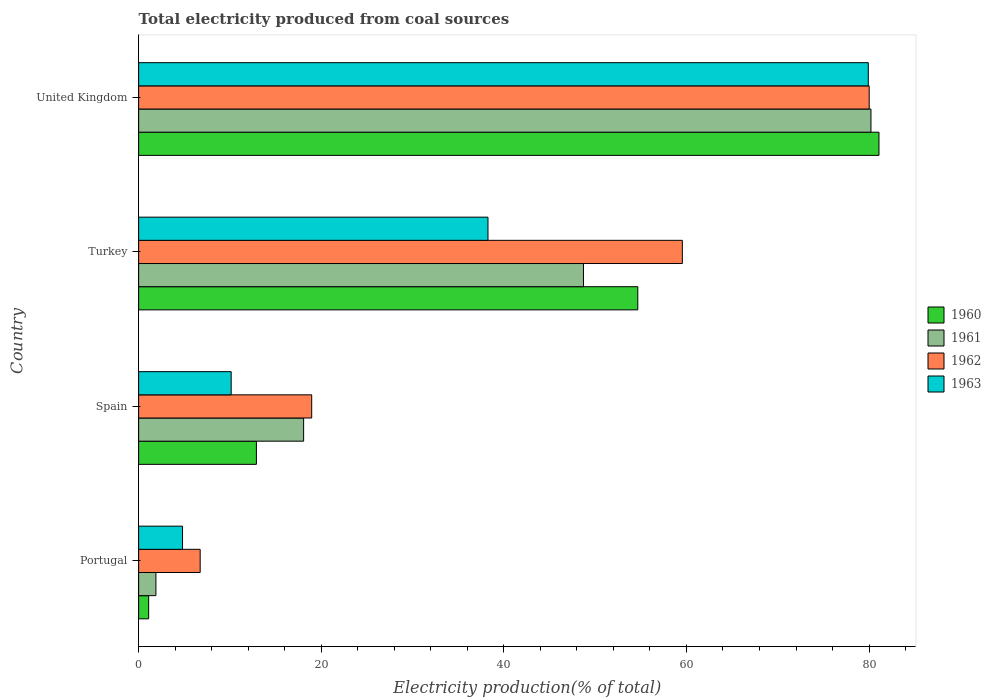How many different coloured bars are there?
Keep it short and to the point. 4. How many groups of bars are there?
Ensure brevity in your answer.  4. How many bars are there on the 3rd tick from the bottom?
Keep it short and to the point. 4. In how many cases, is the number of bars for a given country not equal to the number of legend labels?
Make the answer very short. 0. What is the total electricity produced in 1961 in Turkey?
Keep it short and to the point. 48.72. Across all countries, what is the maximum total electricity produced in 1963?
Offer a terse response. 79.91. Across all countries, what is the minimum total electricity produced in 1961?
Offer a terse response. 1.89. In which country was the total electricity produced in 1960 minimum?
Your response must be concise. Portugal. What is the total total electricity produced in 1961 in the graph?
Make the answer very short. 148.89. What is the difference between the total electricity produced in 1962 in Portugal and that in Spain?
Give a very brief answer. -12.22. What is the difference between the total electricity produced in 1961 in Portugal and the total electricity produced in 1963 in United Kingdom?
Offer a terse response. -78.02. What is the average total electricity produced in 1961 per country?
Offer a very short reply. 37.22. What is the difference between the total electricity produced in 1961 and total electricity produced in 1963 in Portugal?
Offer a terse response. -2.91. What is the ratio of the total electricity produced in 1963 in Portugal to that in United Kingdom?
Offer a very short reply. 0.06. Is the total electricity produced in 1962 in Turkey less than that in United Kingdom?
Provide a short and direct response. Yes. Is the difference between the total electricity produced in 1961 in Portugal and Spain greater than the difference between the total electricity produced in 1963 in Portugal and Spain?
Give a very brief answer. No. What is the difference between the highest and the second highest total electricity produced in 1961?
Keep it short and to the point. 31.49. What is the difference between the highest and the lowest total electricity produced in 1960?
Provide a succinct answer. 79.99. In how many countries, is the total electricity produced in 1963 greater than the average total electricity produced in 1963 taken over all countries?
Your answer should be very brief. 2. What does the 1st bar from the top in Portugal represents?
Your response must be concise. 1963. What does the 3rd bar from the bottom in United Kingdom represents?
Make the answer very short. 1962. Are all the bars in the graph horizontal?
Offer a very short reply. Yes. What is the difference between two consecutive major ticks on the X-axis?
Offer a terse response. 20. Where does the legend appear in the graph?
Your answer should be very brief. Center right. How are the legend labels stacked?
Your answer should be compact. Vertical. What is the title of the graph?
Ensure brevity in your answer.  Total electricity produced from coal sources. Does "1976" appear as one of the legend labels in the graph?
Give a very brief answer. No. What is the Electricity production(% of total) of 1960 in Portugal?
Your answer should be very brief. 1.1. What is the Electricity production(% of total) of 1961 in Portugal?
Provide a short and direct response. 1.89. What is the Electricity production(% of total) in 1962 in Portugal?
Provide a succinct answer. 6.74. What is the Electricity production(% of total) in 1963 in Portugal?
Keep it short and to the point. 4.81. What is the Electricity production(% of total) in 1960 in Spain?
Keep it short and to the point. 12.9. What is the Electricity production(% of total) of 1961 in Spain?
Provide a short and direct response. 18.07. What is the Electricity production(% of total) in 1962 in Spain?
Make the answer very short. 18.96. What is the Electricity production(% of total) of 1963 in Spain?
Offer a very short reply. 10.14. What is the Electricity production(% of total) of 1960 in Turkey?
Keep it short and to the point. 54.67. What is the Electricity production(% of total) of 1961 in Turkey?
Provide a succinct answer. 48.72. What is the Electricity production(% of total) of 1962 in Turkey?
Offer a terse response. 59.55. What is the Electricity production(% of total) of 1963 in Turkey?
Make the answer very short. 38.26. What is the Electricity production(% of total) of 1960 in United Kingdom?
Make the answer very short. 81.09. What is the Electricity production(% of total) of 1961 in United Kingdom?
Offer a terse response. 80.21. What is the Electricity production(% of total) in 1962 in United Kingdom?
Keep it short and to the point. 80.01. What is the Electricity production(% of total) of 1963 in United Kingdom?
Give a very brief answer. 79.91. Across all countries, what is the maximum Electricity production(% of total) of 1960?
Your response must be concise. 81.09. Across all countries, what is the maximum Electricity production(% of total) in 1961?
Make the answer very short. 80.21. Across all countries, what is the maximum Electricity production(% of total) in 1962?
Your answer should be very brief. 80.01. Across all countries, what is the maximum Electricity production(% of total) in 1963?
Your answer should be very brief. 79.91. Across all countries, what is the minimum Electricity production(% of total) of 1960?
Your answer should be very brief. 1.1. Across all countries, what is the minimum Electricity production(% of total) in 1961?
Make the answer very short. 1.89. Across all countries, what is the minimum Electricity production(% of total) of 1962?
Make the answer very short. 6.74. Across all countries, what is the minimum Electricity production(% of total) in 1963?
Offer a very short reply. 4.81. What is the total Electricity production(% of total) in 1960 in the graph?
Your answer should be compact. 149.75. What is the total Electricity production(% of total) of 1961 in the graph?
Keep it short and to the point. 148.89. What is the total Electricity production(% of total) in 1962 in the graph?
Offer a very short reply. 165.26. What is the total Electricity production(% of total) of 1963 in the graph?
Offer a very short reply. 133.12. What is the difference between the Electricity production(% of total) of 1960 in Portugal and that in Spain?
Keep it short and to the point. -11.8. What is the difference between the Electricity production(% of total) in 1961 in Portugal and that in Spain?
Provide a short and direct response. -16.18. What is the difference between the Electricity production(% of total) in 1962 in Portugal and that in Spain?
Keep it short and to the point. -12.22. What is the difference between the Electricity production(% of total) of 1963 in Portugal and that in Spain?
Your response must be concise. -5.33. What is the difference between the Electricity production(% of total) in 1960 in Portugal and that in Turkey?
Provide a succinct answer. -53.57. What is the difference between the Electricity production(% of total) of 1961 in Portugal and that in Turkey?
Make the answer very short. -46.83. What is the difference between the Electricity production(% of total) of 1962 in Portugal and that in Turkey?
Your answer should be very brief. -52.81. What is the difference between the Electricity production(% of total) of 1963 in Portugal and that in Turkey?
Your response must be concise. -33.45. What is the difference between the Electricity production(% of total) in 1960 in Portugal and that in United Kingdom?
Keep it short and to the point. -79.99. What is the difference between the Electricity production(% of total) of 1961 in Portugal and that in United Kingdom?
Your response must be concise. -78.31. What is the difference between the Electricity production(% of total) of 1962 in Portugal and that in United Kingdom?
Your answer should be compact. -73.27. What is the difference between the Electricity production(% of total) of 1963 in Portugal and that in United Kingdom?
Make the answer very short. -75.1. What is the difference between the Electricity production(% of total) in 1960 in Spain and that in Turkey?
Make the answer very short. -41.77. What is the difference between the Electricity production(% of total) in 1961 in Spain and that in Turkey?
Offer a terse response. -30.65. What is the difference between the Electricity production(% of total) of 1962 in Spain and that in Turkey?
Your answer should be compact. -40.59. What is the difference between the Electricity production(% of total) in 1963 in Spain and that in Turkey?
Make the answer very short. -28.13. What is the difference between the Electricity production(% of total) of 1960 in Spain and that in United Kingdom?
Give a very brief answer. -68.19. What is the difference between the Electricity production(% of total) of 1961 in Spain and that in United Kingdom?
Provide a short and direct response. -62.14. What is the difference between the Electricity production(% of total) of 1962 in Spain and that in United Kingdom?
Your answer should be compact. -61.06. What is the difference between the Electricity production(% of total) in 1963 in Spain and that in United Kingdom?
Offer a terse response. -69.78. What is the difference between the Electricity production(% of total) of 1960 in Turkey and that in United Kingdom?
Your answer should be very brief. -26.41. What is the difference between the Electricity production(% of total) of 1961 in Turkey and that in United Kingdom?
Make the answer very short. -31.49. What is the difference between the Electricity production(% of total) in 1962 in Turkey and that in United Kingdom?
Offer a terse response. -20.46. What is the difference between the Electricity production(% of total) in 1963 in Turkey and that in United Kingdom?
Provide a short and direct response. -41.65. What is the difference between the Electricity production(% of total) of 1960 in Portugal and the Electricity production(% of total) of 1961 in Spain?
Ensure brevity in your answer.  -16.97. What is the difference between the Electricity production(% of total) in 1960 in Portugal and the Electricity production(% of total) in 1962 in Spain?
Ensure brevity in your answer.  -17.86. What is the difference between the Electricity production(% of total) of 1960 in Portugal and the Electricity production(% of total) of 1963 in Spain?
Offer a very short reply. -9.04. What is the difference between the Electricity production(% of total) in 1961 in Portugal and the Electricity production(% of total) in 1962 in Spain?
Offer a very short reply. -17.06. What is the difference between the Electricity production(% of total) of 1961 in Portugal and the Electricity production(% of total) of 1963 in Spain?
Ensure brevity in your answer.  -8.24. What is the difference between the Electricity production(% of total) of 1962 in Portugal and the Electricity production(% of total) of 1963 in Spain?
Ensure brevity in your answer.  -3.4. What is the difference between the Electricity production(% of total) of 1960 in Portugal and the Electricity production(% of total) of 1961 in Turkey?
Keep it short and to the point. -47.62. What is the difference between the Electricity production(% of total) in 1960 in Portugal and the Electricity production(% of total) in 1962 in Turkey?
Offer a terse response. -58.45. What is the difference between the Electricity production(% of total) of 1960 in Portugal and the Electricity production(% of total) of 1963 in Turkey?
Your answer should be compact. -37.16. What is the difference between the Electricity production(% of total) of 1961 in Portugal and the Electricity production(% of total) of 1962 in Turkey?
Offer a terse response. -57.66. What is the difference between the Electricity production(% of total) of 1961 in Portugal and the Electricity production(% of total) of 1963 in Turkey?
Give a very brief answer. -36.37. What is the difference between the Electricity production(% of total) of 1962 in Portugal and the Electricity production(% of total) of 1963 in Turkey?
Offer a very short reply. -31.52. What is the difference between the Electricity production(% of total) of 1960 in Portugal and the Electricity production(% of total) of 1961 in United Kingdom?
Provide a succinct answer. -79.11. What is the difference between the Electricity production(% of total) of 1960 in Portugal and the Electricity production(% of total) of 1962 in United Kingdom?
Give a very brief answer. -78.92. What is the difference between the Electricity production(% of total) of 1960 in Portugal and the Electricity production(% of total) of 1963 in United Kingdom?
Your response must be concise. -78.82. What is the difference between the Electricity production(% of total) in 1961 in Portugal and the Electricity production(% of total) in 1962 in United Kingdom?
Give a very brief answer. -78.12. What is the difference between the Electricity production(% of total) in 1961 in Portugal and the Electricity production(% of total) in 1963 in United Kingdom?
Provide a succinct answer. -78.02. What is the difference between the Electricity production(% of total) in 1962 in Portugal and the Electricity production(% of total) in 1963 in United Kingdom?
Your response must be concise. -73.17. What is the difference between the Electricity production(% of total) of 1960 in Spain and the Electricity production(% of total) of 1961 in Turkey?
Make the answer very short. -35.82. What is the difference between the Electricity production(% of total) in 1960 in Spain and the Electricity production(% of total) in 1962 in Turkey?
Provide a short and direct response. -46.65. What is the difference between the Electricity production(% of total) in 1960 in Spain and the Electricity production(% of total) in 1963 in Turkey?
Ensure brevity in your answer.  -25.36. What is the difference between the Electricity production(% of total) in 1961 in Spain and the Electricity production(% of total) in 1962 in Turkey?
Offer a terse response. -41.48. What is the difference between the Electricity production(% of total) in 1961 in Spain and the Electricity production(% of total) in 1963 in Turkey?
Provide a succinct answer. -20.19. What is the difference between the Electricity production(% of total) in 1962 in Spain and the Electricity production(% of total) in 1963 in Turkey?
Provide a succinct answer. -19.31. What is the difference between the Electricity production(% of total) of 1960 in Spain and the Electricity production(% of total) of 1961 in United Kingdom?
Your answer should be very brief. -67.31. What is the difference between the Electricity production(% of total) of 1960 in Spain and the Electricity production(% of total) of 1962 in United Kingdom?
Keep it short and to the point. -67.12. What is the difference between the Electricity production(% of total) of 1960 in Spain and the Electricity production(% of total) of 1963 in United Kingdom?
Provide a short and direct response. -67.02. What is the difference between the Electricity production(% of total) in 1961 in Spain and the Electricity production(% of total) in 1962 in United Kingdom?
Ensure brevity in your answer.  -61.94. What is the difference between the Electricity production(% of total) in 1961 in Spain and the Electricity production(% of total) in 1963 in United Kingdom?
Give a very brief answer. -61.84. What is the difference between the Electricity production(% of total) of 1962 in Spain and the Electricity production(% of total) of 1963 in United Kingdom?
Provide a short and direct response. -60.96. What is the difference between the Electricity production(% of total) in 1960 in Turkey and the Electricity production(% of total) in 1961 in United Kingdom?
Give a very brief answer. -25.54. What is the difference between the Electricity production(% of total) of 1960 in Turkey and the Electricity production(% of total) of 1962 in United Kingdom?
Provide a short and direct response. -25.34. What is the difference between the Electricity production(% of total) in 1960 in Turkey and the Electricity production(% of total) in 1963 in United Kingdom?
Your response must be concise. -25.24. What is the difference between the Electricity production(% of total) of 1961 in Turkey and the Electricity production(% of total) of 1962 in United Kingdom?
Make the answer very short. -31.29. What is the difference between the Electricity production(% of total) in 1961 in Turkey and the Electricity production(% of total) in 1963 in United Kingdom?
Give a very brief answer. -31.19. What is the difference between the Electricity production(% of total) in 1962 in Turkey and the Electricity production(% of total) in 1963 in United Kingdom?
Offer a terse response. -20.36. What is the average Electricity production(% of total) of 1960 per country?
Keep it short and to the point. 37.44. What is the average Electricity production(% of total) of 1961 per country?
Ensure brevity in your answer.  37.22. What is the average Electricity production(% of total) of 1962 per country?
Provide a short and direct response. 41.32. What is the average Electricity production(% of total) of 1963 per country?
Your response must be concise. 33.28. What is the difference between the Electricity production(% of total) in 1960 and Electricity production(% of total) in 1961 in Portugal?
Your answer should be very brief. -0.8. What is the difference between the Electricity production(% of total) in 1960 and Electricity production(% of total) in 1962 in Portugal?
Provide a succinct answer. -5.64. What is the difference between the Electricity production(% of total) in 1960 and Electricity production(% of total) in 1963 in Portugal?
Make the answer very short. -3.71. What is the difference between the Electricity production(% of total) of 1961 and Electricity production(% of total) of 1962 in Portugal?
Provide a short and direct response. -4.85. What is the difference between the Electricity production(% of total) in 1961 and Electricity production(% of total) in 1963 in Portugal?
Your response must be concise. -2.91. What is the difference between the Electricity production(% of total) in 1962 and Electricity production(% of total) in 1963 in Portugal?
Give a very brief answer. 1.93. What is the difference between the Electricity production(% of total) in 1960 and Electricity production(% of total) in 1961 in Spain?
Make the answer very short. -5.17. What is the difference between the Electricity production(% of total) in 1960 and Electricity production(% of total) in 1962 in Spain?
Give a very brief answer. -6.06. What is the difference between the Electricity production(% of total) of 1960 and Electricity production(% of total) of 1963 in Spain?
Provide a short and direct response. 2.76. What is the difference between the Electricity production(% of total) in 1961 and Electricity production(% of total) in 1962 in Spain?
Make the answer very short. -0.88. What is the difference between the Electricity production(% of total) of 1961 and Electricity production(% of total) of 1963 in Spain?
Offer a terse response. 7.94. What is the difference between the Electricity production(% of total) in 1962 and Electricity production(% of total) in 1963 in Spain?
Your answer should be very brief. 8.82. What is the difference between the Electricity production(% of total) in 1960 and Electricity production(% of total) in 1961 in Turkey?
Your answer should be very brief. 5.95. What is the difference between the Electricity production(% of total) in 1960 and Electricity production(% of total) in 1962 in Turkey?
Keep it short and to the point. -4.88. What is the difference between the Electricity production(% of total) of 1960 and Electricity production(% of total) of 1963 in Turkey?
Make the answer very short. 16.41. What is the difference between the Electricity production(% of total) of 1961 and Electricity production(% of total) of 1962 in Turkey?
Make the answer very short. -10.83. What is the difference between the Electricity production(% of total) in 1961 and Electricity production(% of total) in 1963 in Turkey?
Ensure brevity in your answer.  10.46. What is the difference between the Electricity production(% of total) of 1962 and Electricity production(% of total) of 1963 in Turkey?
Your answer should be very brief. 21.29. What is the difference between the Electricity production(% of total) of 1960 and Electricity production(% of total) of 1961 in United Kingdom?
Make the answer very short. 0.88. What is the difference between the Electricity production(% of total) of 1960 and Electricity production(% of total) of 1962 in United Kingdom?
Your response must be concise. 1.07. What is the difference between the Electricity production(% of total) in 1960 and Electricity production(% of total) in 1963 in United Kingdom?
Offer a very short reply. 1.17. What is the difference between the Electricity production(% of total) of 1961 and Electricity production(% of total) of 1962 in United Kingdom?
Offer a very short reply. 0.19. What is the difference between the Electricity production(% of total) in 1961 and Electricity production(% of total) in 1963 in United Kingdom?
Provide a short and direct response. 0.29. What is the difference between the Electricity production(% of total) of 1962 and Electricity production(% of total) of 1963 in United Kingdom?
Provide a short and direct response. 0.1. What is the ratio of the Electricity production(% of total) in 1960 in Portugal to that in Spain?
Ensure brevity in your answer.  0.09. What is the ratio of the Electricity production(% of total) in 1961 in Portugal to that in Spain?
Provide a succinct answer. 0.1. What is the ratio of the Electricity production(% of total) of 1962 in Portugal to that in Spain?
Your answer should be compact. 0.36. What is the ratio of the Electricity production(% of total) in 1963 in Portugal to that in Spain?
Provide a succinct answer. 0.47. What is the ratio of the Electricity production(% of total) in 1960 in Portugal to that in Turkey?
Give a very brief answer. 0.02. What is the ratio of the Electricity production(% of total) in 1961 in Portugal to that in Turkey?
Provide a succinct answer. 0.04. What is the ratio of the Electricity production(% of total) in 1962 in Portugal to that in Turkey?
Your answer should be very brief. 0.11. What is the ratio of the Electricity production(% of total) of 1963 in Portugal to that in Turkey?
Offer a very short reply. 0.13. What is the ratio of the Electricity production(% of total) of 1960 in Portugal to that in United Kingdom?
Your answer should be very brief. 0.01. What is the ratio of the Electricity production(% of total) of 1961 in Portugal to that in United Kingdom?
Offer a terse response. 0.02. What is the ratio of the Electricity production(% of total) in 1962 in Portugal to that in United Kingdom?
Your answer should be compact. 0.08. What is the ratio of the Electricity production(% of total) of 1963 in Portugal to that in United Kingdom?
Make the answer very short. 0.06. What is the ratio of the Electricity production(% of total) in 1960 in Spain to that in Turkey?
Give a very brief answer. 0.24. What is the ratio of the Electricity production(% of total) in 1961 in Spain to that in Turkey?
Ensure brevity in your answer.  0.37. What is the ratio of the Electricity production(% of total) of 1962 in Spain to that in Turkey?
Provide a short and direct response. 0.32. What is the ratio of the Electricity production(% of total) in 1963 in Spain to that in Turkey?
Provide a short and direct response. 0.26. What is the ratio of the Electricity production(% of total) of 1960 in Spain to that in United Kingdom?
Keep it short and to the point. 0.16. What is the ratio of the Electricity production(% of total) of 1961 in Spain to that in United Kingdom?
Ensure brevity in your answer.  0.23. What is the ratio of the Electricity production(% of total) in 1962 in Spain to that in United Kingdom?
Offer a very short reply. 0.24. What is the ratio of the Electricity production(% of total) in 1963 in Spain to that in United Kingdom?
Your answer should be very brief. 0.13. What is the ratio of the Electricity production(% of total) in 1960 in Turkey to that in United Kingdom?
Your response must be concise. 0.67. What is the ratio of the Electricity production(% of total) in 1961 in Turkey to that in United Kingdom?
Offer a very short reply. 0.61. What is the ratio of the Electricity production(% of total) in 1962 in Turkey to that in United Kingdom?
Offer a very short reply. 0.74. What is the ratio of the Electricity production(% of total) of 1963 in Turkey to that in United Kingdom?
Ensure brevity in your answer.  0.48. What is the difference between the highest and the second highest Electricity production(% of total) in 1960?
Make the answer very short. 26.41. What is the difference between the highest and the second highest Electricity production(% of total) of 1961?
Make the answer very short. 31.49. What is the difference between the highest and the second highest Electricity production(% of total) in 1962?
Your answer should be very brief. 20.46. What is the difference between the highest and the second highest Electricity production(% of total) in 1963?
Give a very brief answer. 41.65. What is the difference between the highest and the lowest Electricity production(% of total) in 1960?
Make the answer very short. 79.99. What is the difference between the highest and the lowest Electricity production(% of total) in 1961?
Ensure brevity in your answer.  78.31. What is the difference between the highest and the lowest Electricity production(% of total) in 1962?
Offer a terse response. 73.27. What is the difference between the highest and the lowest Electricity production(% of total) of 1963?
Your answer should be very brief. 75.1. 